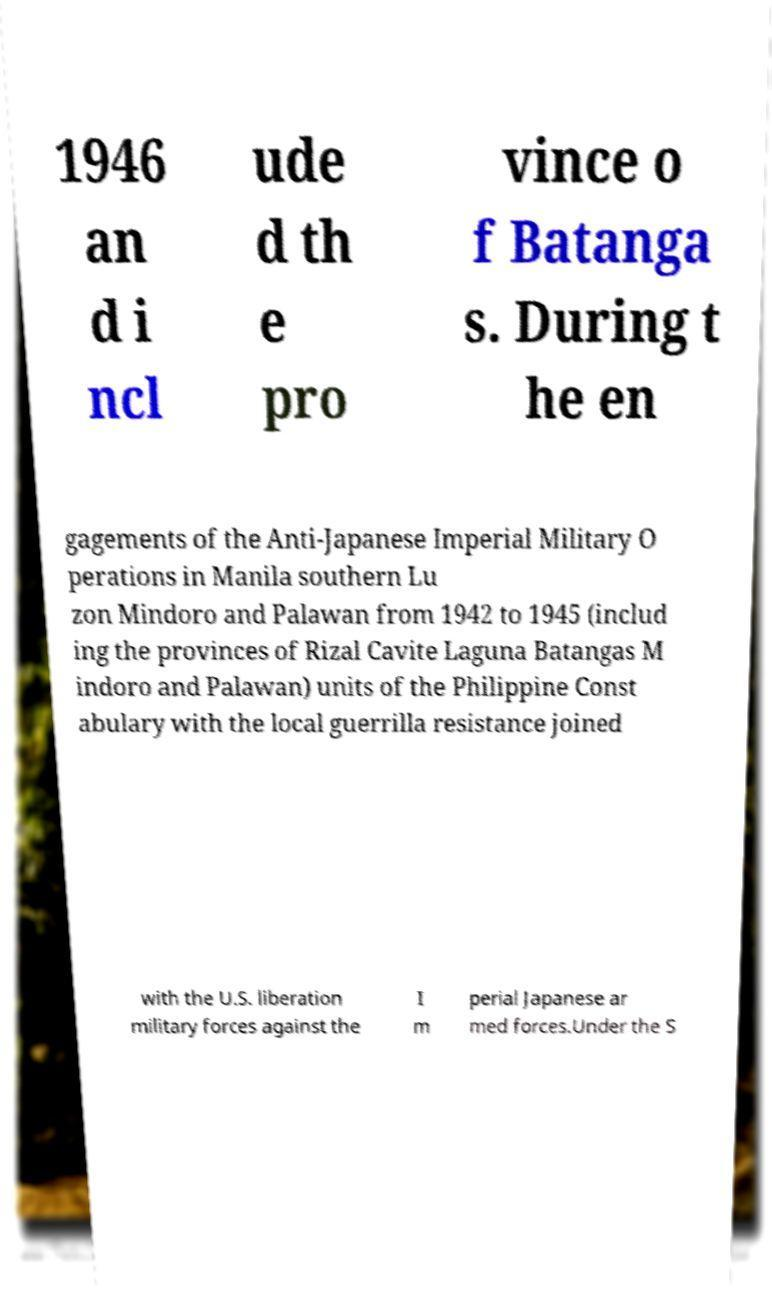For documentation purposes, I need the text within this image transcribed. Could you provide that? 1946 an d i ncl ude d th e pro vince o f Batanga s. During t he en gagements of the Anti-Japanese Imperial Military O perations in Manila southern Lu zon Mindoro and Palawan from 1942 to 1945 (includ ing the provinces of Rizal Cavite Laguna Batangas M indoro and Palawan) units of the Philippine Const abulary with the local guerrilla resistance joined with the U.S. liberation military forces against the I m perial Japanese ar med forces.Under the S 